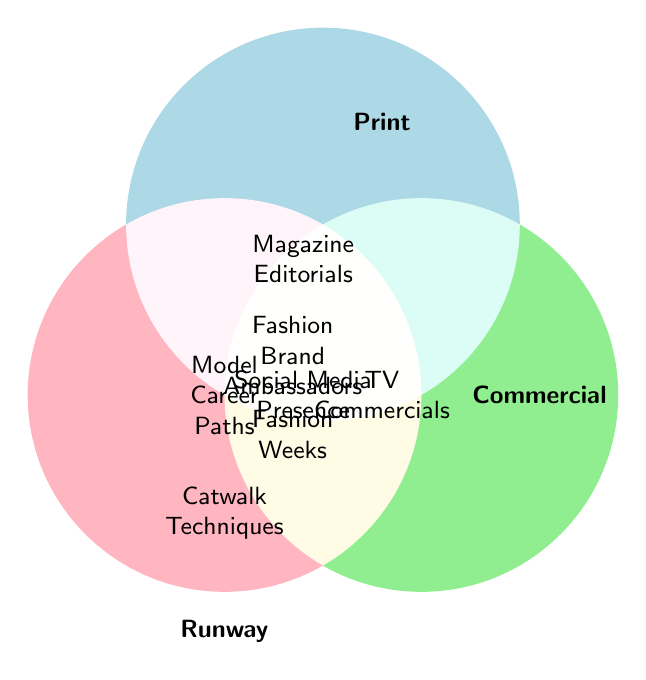What are the career paths exclusively associated with Runway modeling? To find this, we need to look at the section of the Venn Diagram solely within the 'Runway' circle and not overlapping any other circles.
Answer: Haute Couture, Paris Fashion Week, Catwalk Techniques, Designer Showrooms Which career paths are common between Print and Commercial modeling but not Runway? This covers the intersection area between the 'Print' and 'Commercial' circles only.
Answer: No specific career paths fitting this criteria are listed What are the career paths that intersect all three modeling types: Runway, Print, and Commercial? This is found in the central section where all three circles overlap.
Answer: Fashion Brand Ambassadors, Social Media Presence How many categories are unique to Commercial modeling only? Look at the sectors within the 'Commercial' circle but outside 'Runway' and 'Print' circles.
Answer: TV Commercials, Product Catalogs, E-commerce Modeling, Lifestyle Ads, Infomercials, Department Store Ads Are there any career paths shared only between Runway and Print modeling? Check the overlapping area between 'Runway' and 'Print' circles that excludes 'Commercial'.
Answer: Vogue Covers 